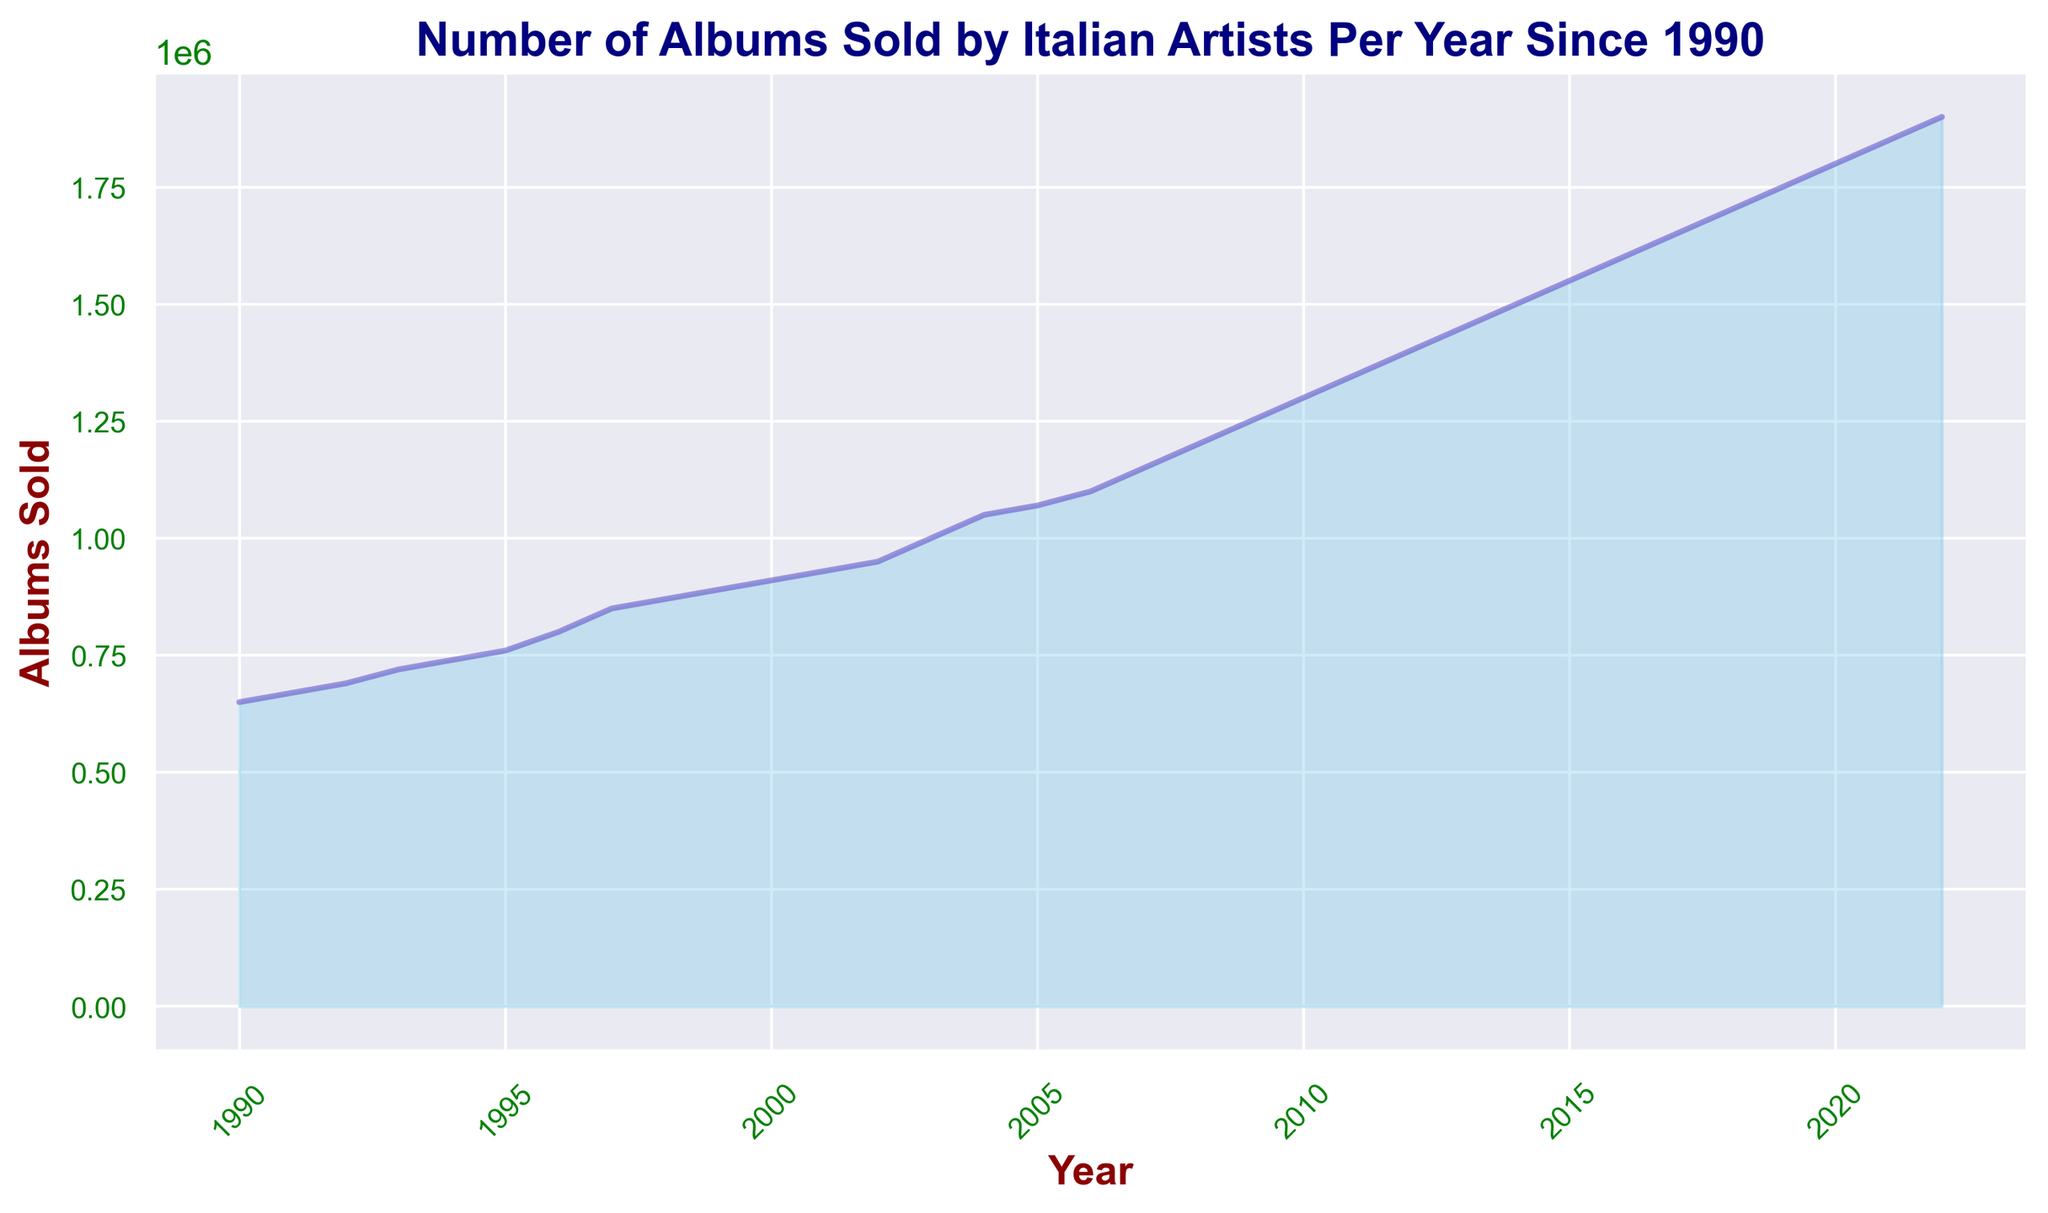What's the highest number of albums sold in a year? The chart shows the number of albums sold increasing each year. To find the highest number, look at the last year on the x-axis and its corresponding y-value. The figure indicates this point as 2022.
Answer: 1,900,000 Which year saw the first significant increase in albums sold? The chart visually indicates the first significant increase by an upward slope starting earlier in the series. From 1992 to 1993, the increase in albums sold appears more prominent than previous years.
Answer: 1993 By how much did album sales increase from 2000 to 2005? To find the increase in number of albums sold between these years, identify the y-values corresponding to 2000 and 2005 and subtract the earlier from the latter. In 2000, it was 910,000 and in 2005 it was 1,070,000.
Answer: 160,000 Compare the album sales in 1995 with 2005. Which year had higher sales and by how much? Determine the respective y-values for 1995 and 2005 from the chart. In 1995, album sales were 760,000, whereas in 2005 they were 1,070,000. Subtract the values to find the difference.
Answer: 2005 by 310,000 What is the average annual increase in album sales between 1990 and 2022? Calculate the total increase in album sales from 1990 to 2022 and divide by the number of years. The increase from 650,000 in 1990 to 1,900,000 in 2022 is 1,250,000. Dividing by the 32-year span gives the average annual increase.
Answer: 39,062.5 Which five-year period saw the highest growth in album sales? Divide the chart into five-year periods and assess the slope for each segment. The period from 2008 to 2013 shows steep growth, initially from 1,200,000 in 2008 to 1,450,000 in 2013.
Answer: 2008 to 2013 What is the trend in album sales from 1990 to 2022? Observing the chart from 1990 to 2022, the y-values continually rise each year, showing a clear, consistent upward trend.
Answer: Increasing In which decade did album sales surpass one million for the first time? Identify the year on the graph where album sales reach one million for the first time, then determine the corresponding decade. This first happens in 2003.
Answer: 2000s What was the percentage increase in album sales from 2010 to 2020? Calculate the increase in album sales from 1,300,000 in 2010 to 1,800,000 in 2020, then divide the increase by the 2010 value and multiply by 100 to get the percentage. The calculation is ((1,800,000 - 1,300,000) / 1,300,000) * 100.
Answer: 38.46% Which years experienced the smallest increase in album sales year over year? Observing the graph, the years with flatter slopes indicate smaller increases. From 1990 to 1991, the increase appears minimal with sales going from 650,000 to 670,000.
Answer: 1990 to 1991 